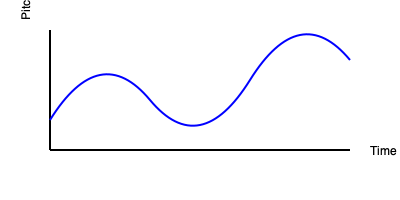Analyze the visual representation of an improvised jazz trumpet melody shown above. What characteristic of jazz improvisation is most prominently illustrated by the shape of this melodic line? To answer this question, let's analyze the key features of the melodic line represented in the graph:

1. Non-linear movement: The line doesn't follow a straight path but rather curves and bends unpredictably.

2. Varying pitch: The y-axis represents pitch, and we can see that the line moves up and down frequently, indicating changes in pitch throughout the melody.

3. Irregular intervals: The distance between peaks and valleys in the line varies, suggesting irregular intervals between notes.

4. Continuous flow: Despite the irregularities, the line is unbroken, implying a continuous flow of notes.

5. Unpredictable direction: The overall direction of the line isn't consistently ascending or descending but changes multiple times.

These features, especially the non-linear movement and unpredictable direction, are hallmarks of spontaneity and improvisation in jazz. The melody doesn't follow a predetermined pattern but seems to be created on the spot, which is a fundamental aspect of jazz improvisation.

The most prominent characteristic illustrated by this melodic line is the spontaneity and freedom of expression that defines jazz improvisation. The visual representation shows a melody that appears to be created in the moment, with unexpected turns and variations, rather than following a set pattern or scale.
Answer: Spontaneity 